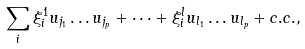Convert formula to latex. <formula><loc_0><loc_0><loc_500><loc_500>\sum _ { i } \xi _ { i } ^ { 1 } u _ { j _ { 1 } } \dots u _ { j _ { p } } + \dots + \xi _ { i } ^ { l } u _ { l _ { 1 } } \dots u _ { l _ { p } } + c . c . ,</formula> 